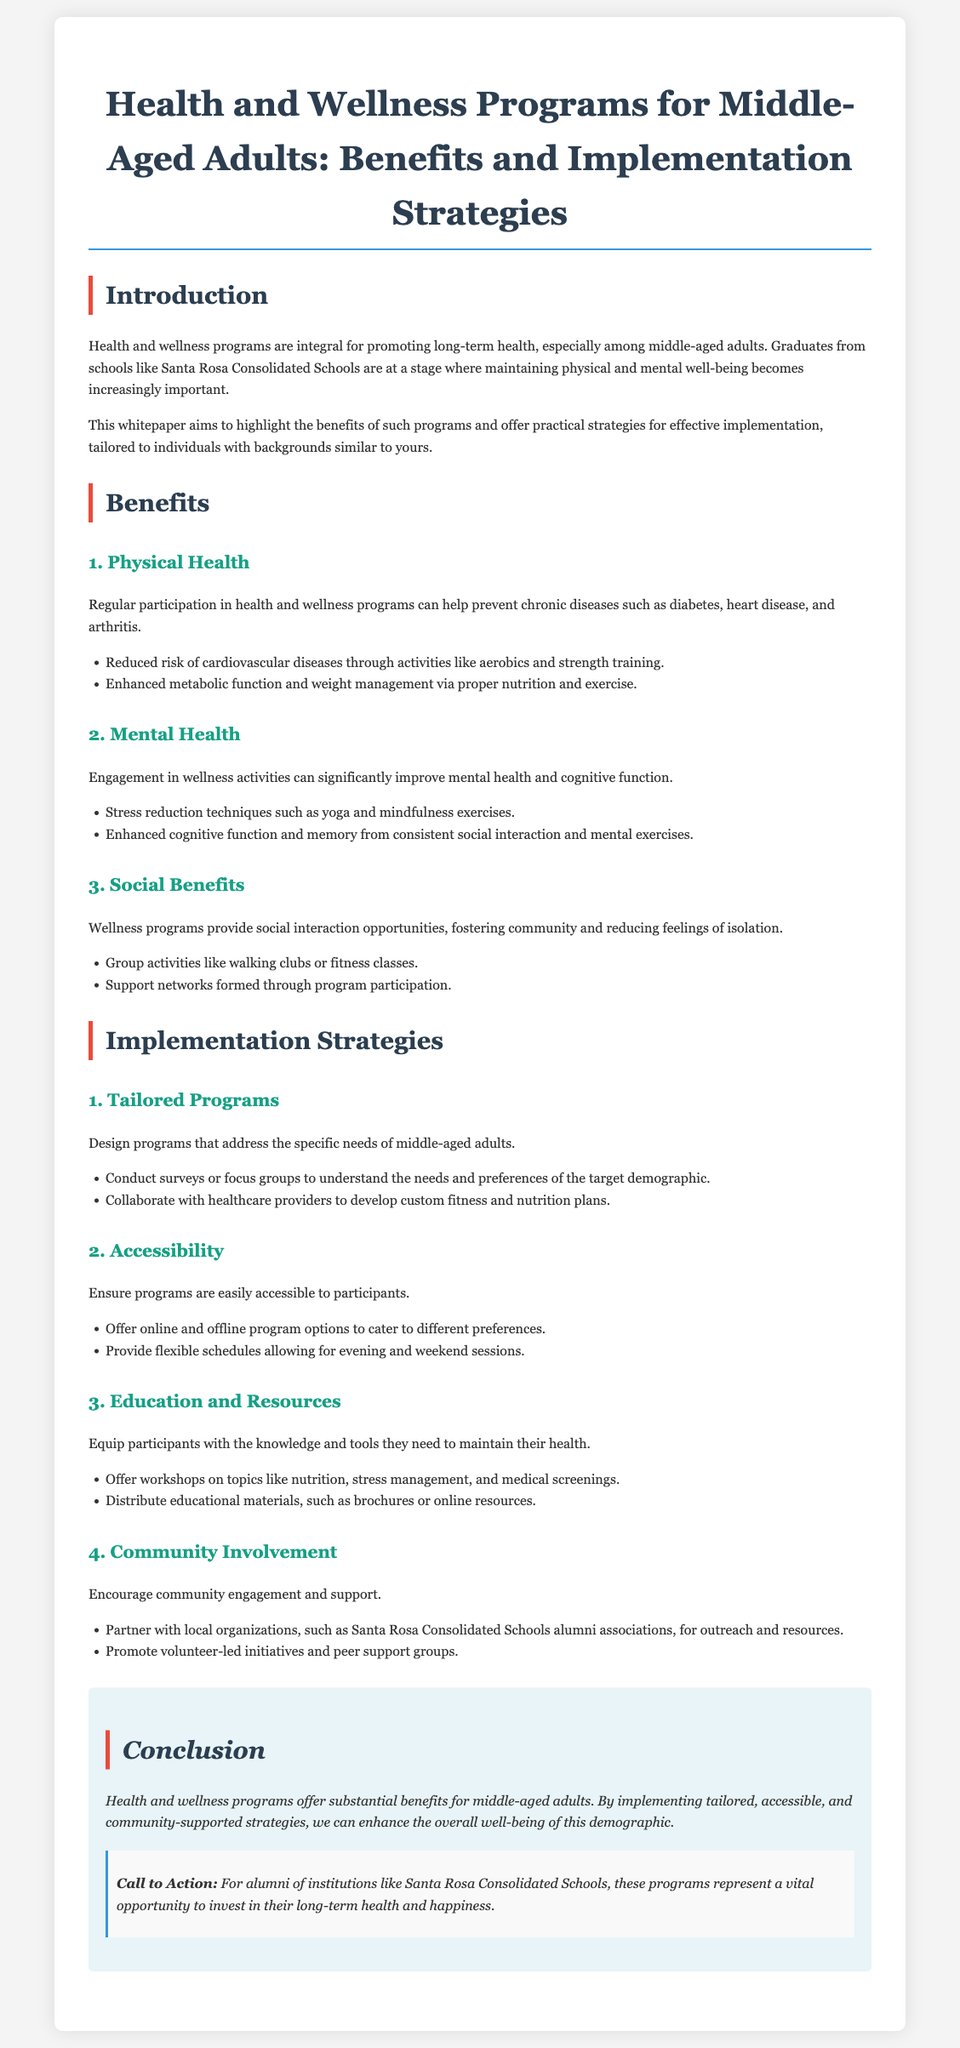What is the title of the whitepaper? The title is stated clearly at the beginning of the document, outlining the main focus of the content.
Answer: Health and Wellness Programs for Middle-Aged Adults: Benefits and Implementation Strategies What is one benefit related to physical health mentioned? This benefit is discussed in the specific section addressing physical health within the benefits of wellness programs.
Answer: Reduced risk of cardiovascular diseases What type of exercise is mentioned as a mental health benefit? The document outlines various techniques for mental health improvement, including specific types of exercises.
Answer: Yoga What is a way to ensure program accessibility? The document provides details on how to improve accessibility, including the incorporation of specific features into program design.
Answer: Offer online and offline program options What should be conducted to understand the needs of middle-aged adults? The implementation strategies section highlights this method as a way to gather information for tailored programs.
Answer: Surveys or focus groups How can community involvement be encouraged? The whitepaper describes several methods for fostering community support and participation, including partnerships with organizations.
Answer: Partner with local organizations What is a resource suggested to equip participants? The document highlights the educational tools necessary for maintaining health, which includes specific types of materials.
Answer: Workshops on nutrition What is the emphasis in the conclusion? The conclusion summarizes the key aspects of the document, particularly focusing on the overall goal of implemented strategies.
Answer: Enhance the overall well-being of this demographic 